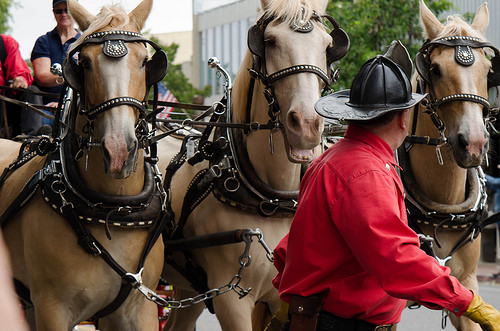<image>
Is there a man behind the horse? No. The man is not behind the horse. From this viewpoint, the man appears to be positioned elsewhere in the scene. 